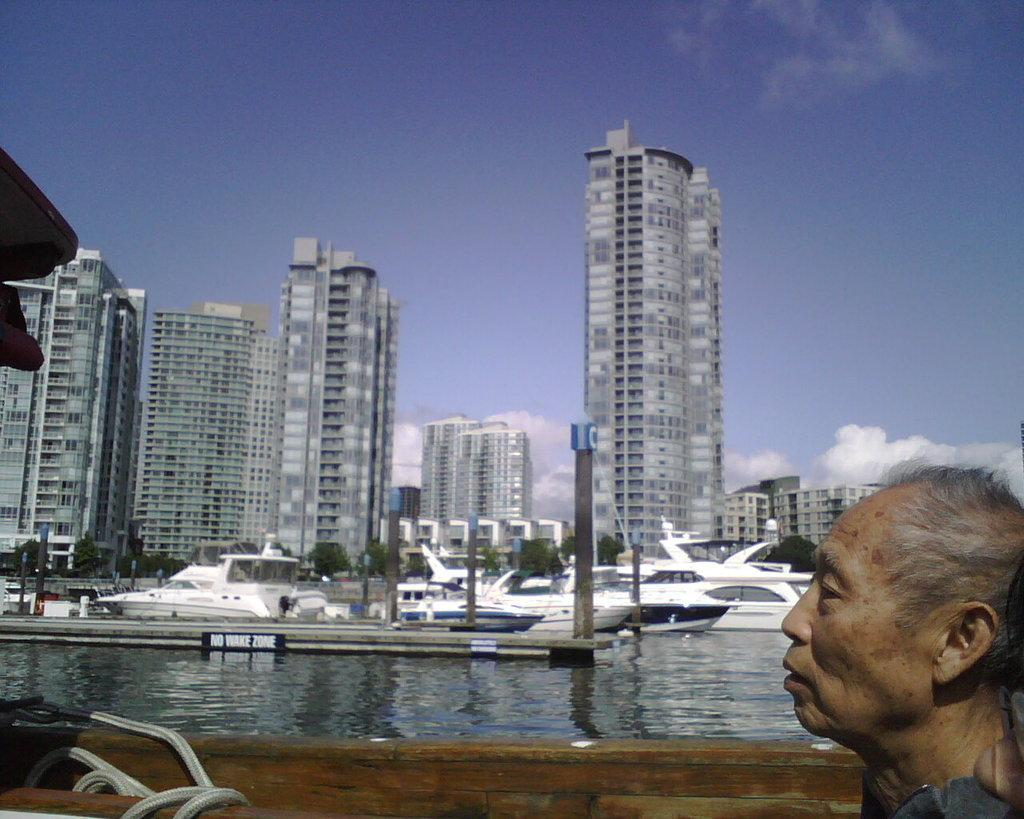What is the main subject of the image? There is a person in the image. What can be seen in the water in the image? There are boats on water in the image. What objects are present in the image that are not related to water or the person? There are poles, trees, and buildings in the image. What is visible in the background of the image? The sky with clouds is visible in the background of the image. What type of noise can be heard coming from the ghost in the image? There is no ghost present in the image, so it is not possible to determine what, if any, noise might be heard. 